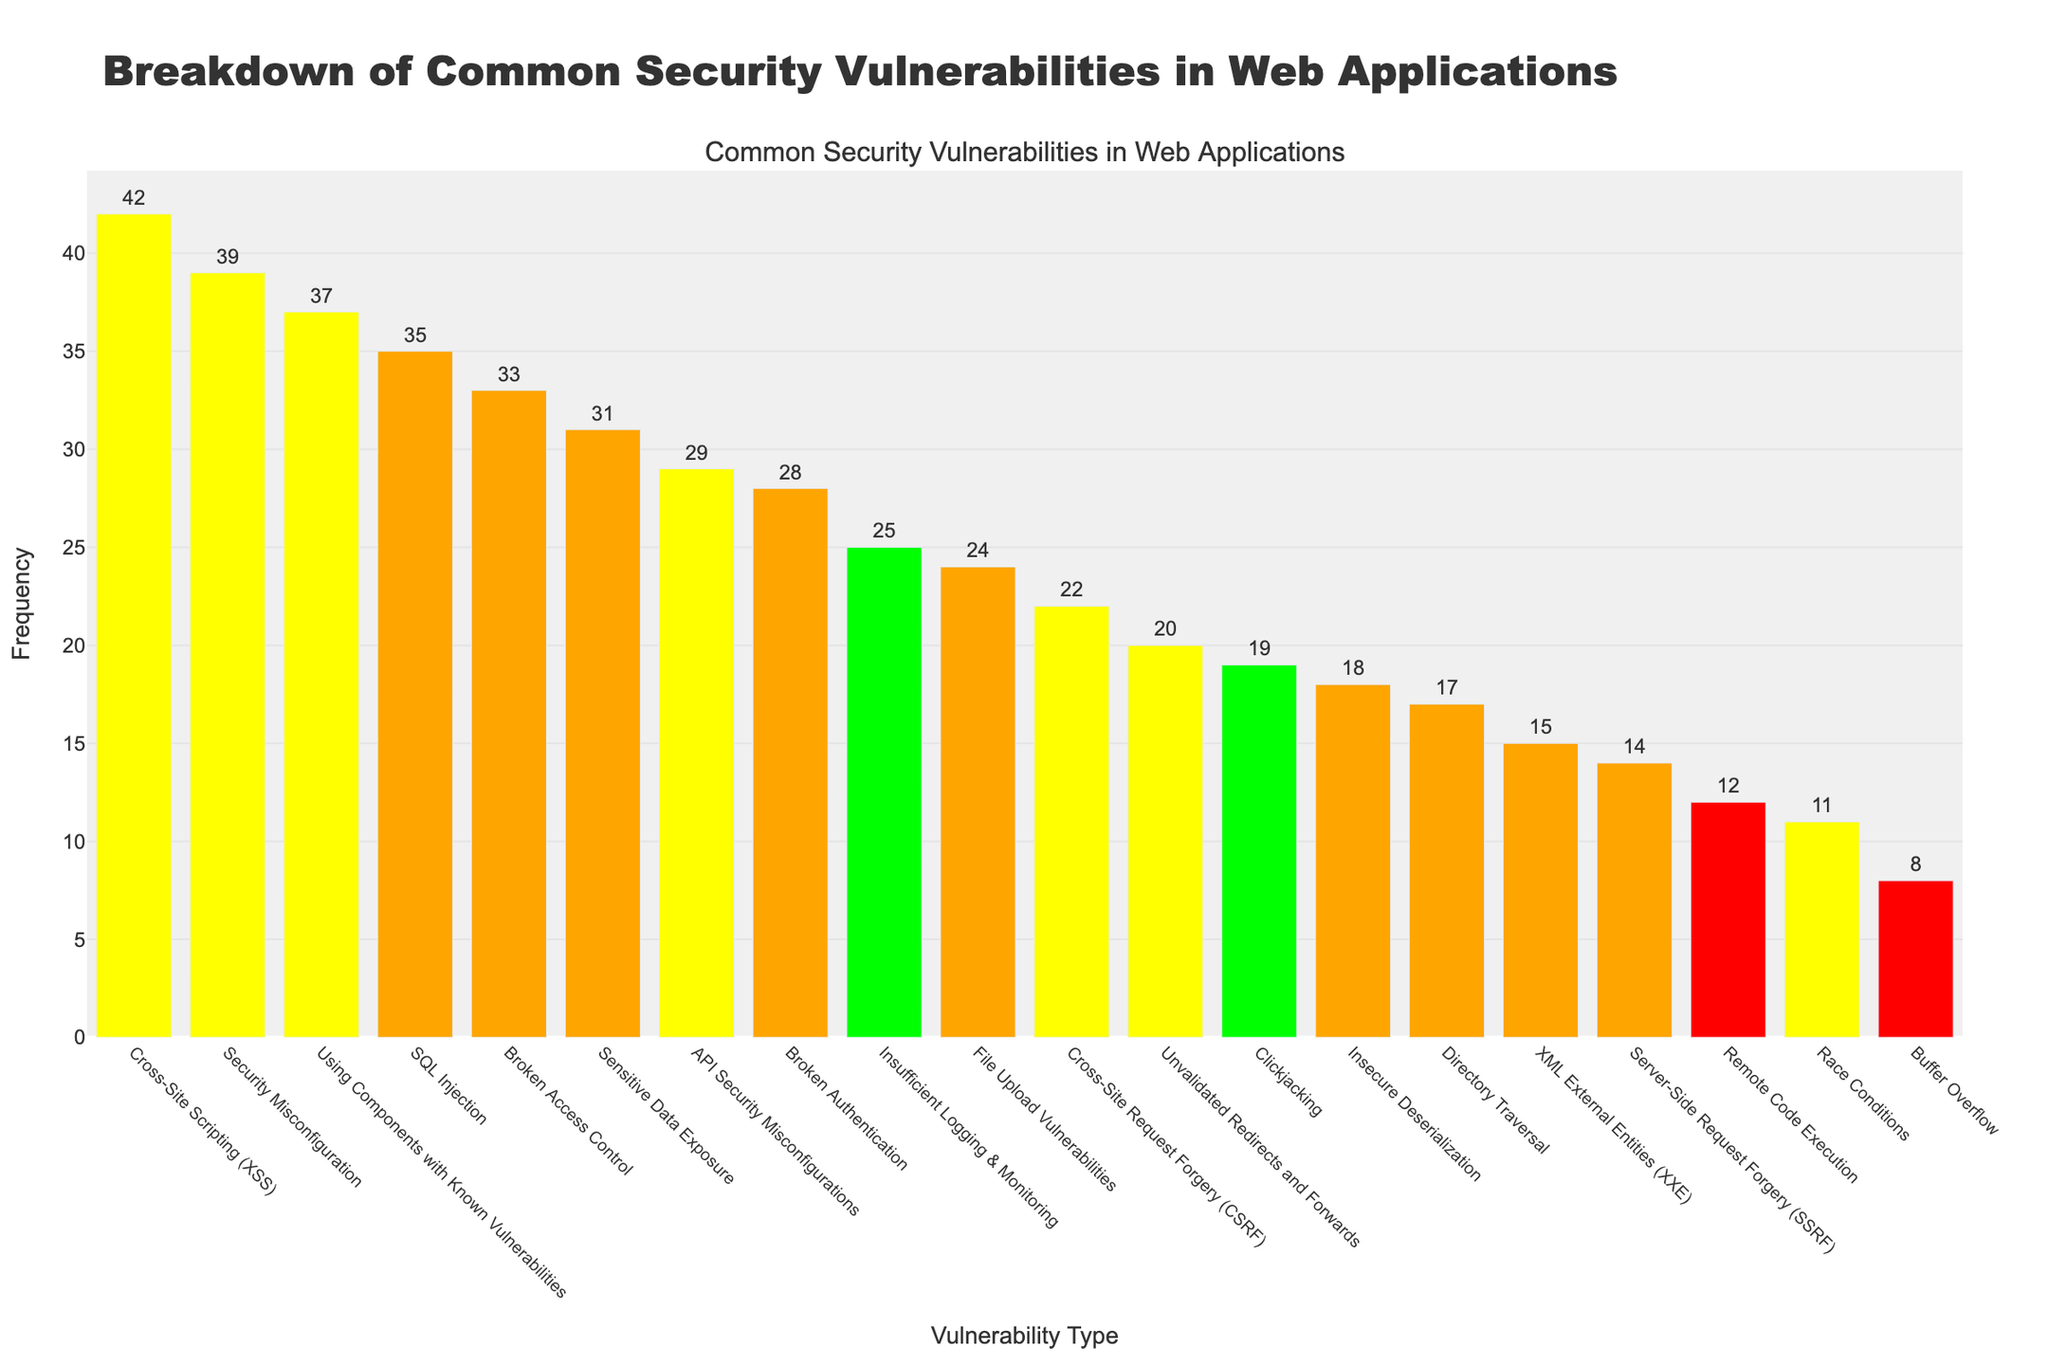Which vulnerability has the highest frequency? The bar representing "Cross-Site Scripting (XSS)" is the tallest, indicating it has the highest frequency among all vulnerabilities listed.
Answer: Cross-Site Scripting (XSS) What is the combined frequency of SQL Injection and Broken Authentication? The frequency of SQL Injection is 35, and the frequency of Broken Authentication is 28. Adding these together gives 35 + 28 = 63.
Answer: 63 Which vulnerabilities are classified as "Critical"? The bars representing "Remote Code Execution" and "Buffer Overflow" are colored red, which represents the "Critical" severity level in the color legend.
Answer: Remote Code Execution, Buffer Overflow What is the frequency difference between the highest and lowest severity categories? The highest frequency in a severity category is "Medium" with a frequency of 42 (Cross-Site Scripting). The lowest frequency in a severity category is "Critical" with a frequency of 8 (Buffer Overflow). The difference is 42 - 8 = 34.
Answer: 34 Which vulnerability has the lowest frequency? The bar representing "Buffer Overflow" is the shortest, indicating it has the lowest frequency.
Answer: Buffer Overflow How many vulnerabilities have a frequency greater than 30? By visually inspecting the heights of the bars, the vulnerabilities with frequencies greater than 30 are SQL Injection (35), Cross-Site Scripting (42), Sensitive Data Exposure (31), and Security Misconfiguration (39).
Answer: 4 Is there a larger number of vulnerabilities with 'High' severity or 'Medium' severity? By counting the bars colored orange (High) and yellow (Medium), we find there are more bars representing 'High' severity (8) compared to 'Medium' severity (6).
Answer: High What is the combined frequency of vulnerabilities with 'Low' severity? The vulnerabilities with 'Low' severity are "Insufficient Logging & Monitoring" (25) and "Clickjacking" (19). Adding these together gives 25 + 19 = 44.
Answer: 44 